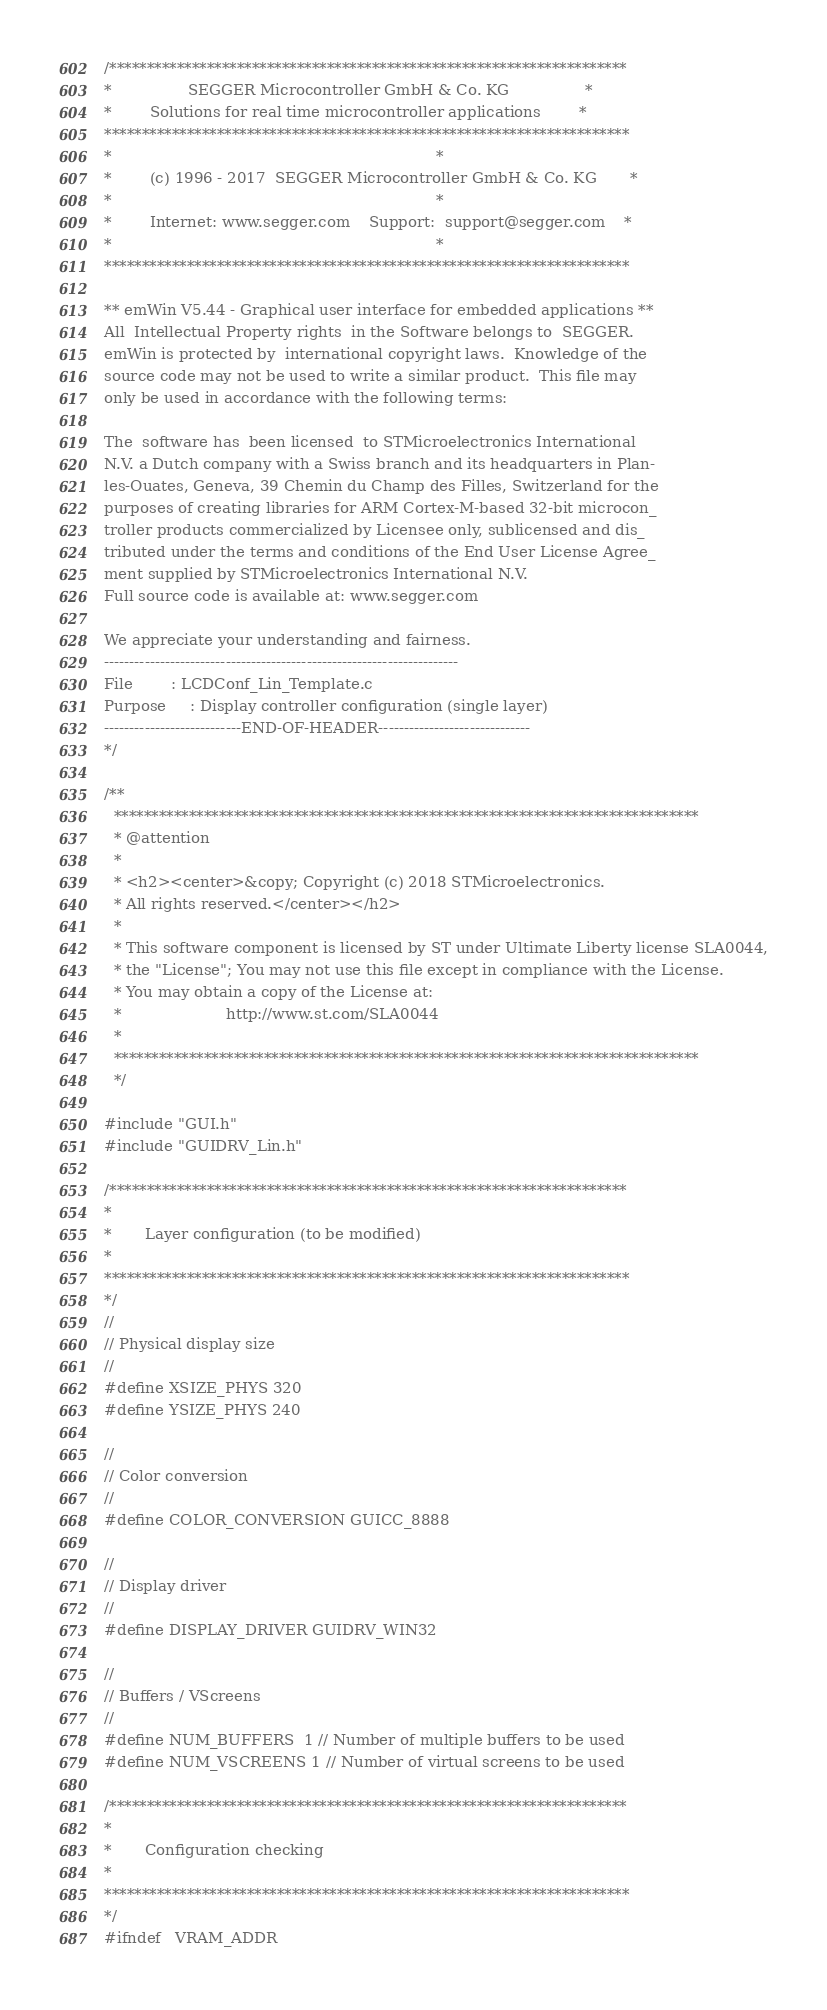Convert code to text. <code><loc_0><loc_0><loc_500><loc_500><_C_>/*********************************************************************
*                SEGGER Microcontroller GmbH & Co. KG                *
*        Solutions for real time microcontroller applications        *
**********************************************************************
*                                                                    *
*        (c) 1996 - 2017  SEGGER Microcontroller GmbH & Co. KG       *
*                                                                    *
*        Internet: www.segger.com    Support:  support@segger.com    *
*                                                                    *
**********************************************************************

** emWin V5.44 - Graphical user interface for embedded applications **
All  Intellectual Property rights  in the Software belongs to  SEGGER.
emWin is protected by  international copyright laws.  Knowledge of the
source code may not be used to write a similar product.  This file may
only be used in accordance with the following terms:

The  software has  been licensed  to STMicroelectronics International
N.V. a Dutch company with a Swiss branch and its headquarters in Plan-
les-Ouates, Geneva, 39 Chemin du Champ des Filles, Switzerland for the
purposes of creating libraries for ARM Cortex-M-based 32-bit microcon_
troller products commercialized by Licensee only, sublicensed and dis_
tributed under the terms and conditions of the End User License Agree_
ment supplied by STMicroelectronics International N.V.
Full source code is available at: www.segger.com

We appreciate your understanding and fairness.
----------------------------------------------------------------------
File        : LCDConf_Lin_Template.c
Purpose     : Display controller configuration (single layer)
---------------------------END-OF-HEADER------------------------------
*/

/**
  ******************************************************************************
  * @attention
  *
  * <h2><center>&copy; Copyright (c) 2018 STMicroelectronics. 
  * All rights reserved.</center></h2>
  *
  * This software component is licensed by ST under Ultimate Liberty license SLA0044,
  * the "License"; You may not use this file except in compliance with the License.
  * You may obtain a copy of the License at:
  *                      http://www.st.com/SLA0044
  *
  ******************************************************************************
  */

#include "GUI.h"
#include "GUIDRV_Lin.h"

/*********************************************************************
*
*       Layer configuration (to be modified)
*
**********************************************************************
*/
//
// Physical display size
//
#define XSIZE_PHYS 320
#define YSIZE_PHYS 240

//
// Color conversion
//
#define COLOR_CONVERSION GUICC_8888

//
// Display driver
//
#define DISPLAY_DRIVER GUIDRV_WIN32

//
// Buffers / VScreens
//
#define NUM_BUFFERS  1 // Number of multiple buffers to be used
#define NUM_VSCREENS 1 // Number of virtual screens to be used

/*********************************************************************
*
*       Configuration checking
*
**********************************************************************
*/
#ifndef   VRAM_ADDR</code> 